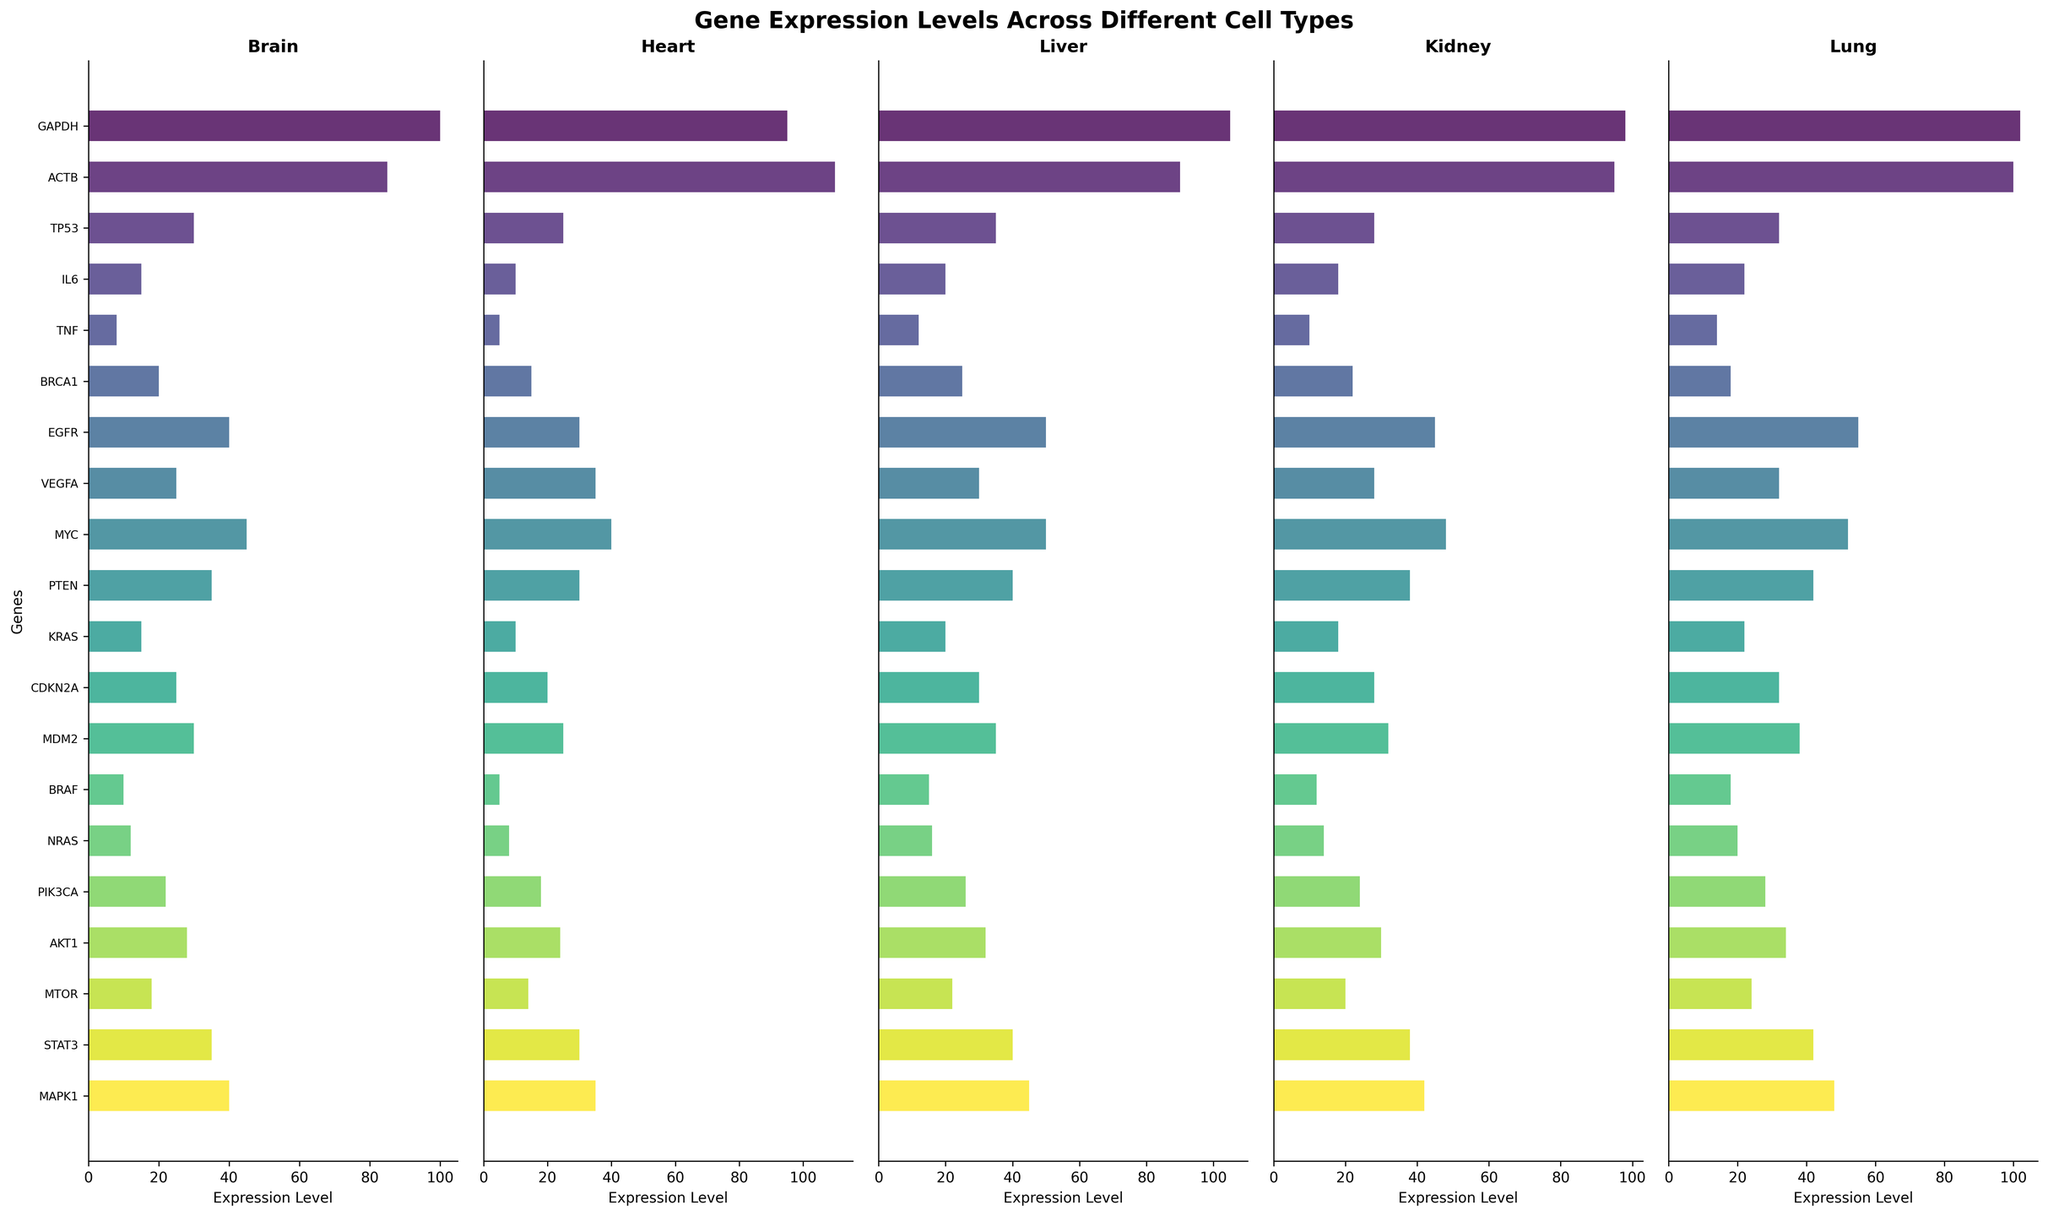What's the highest gene expression level in the Brain? To identify the highest gene expression level in the Brain, examine the heights of the bars in the Brain subplot. The tallest bar corresponds to GAPDH, which has an expression level of 100.
Answer: GAPDH with 100 Compare the expression levels of ACTB in the Liver and Kidney. Which cell type shows higher expression? Check the heights of the ACTB bars in the Liver and Kidney subplots. In the Liver, the expression level of ACTB is 90, while in the Kidney, it is 95. Hence, the Kidney has a higher expression level of ACTB than the Liver.
Answer: Kidney Which three genes have the lowest expression levels in the Heart? To find the three genes with the lowest expression levels in the Heart, look at the three shortest bars in the Heart subplot. These are TNF (5), NRAS (8) and IL6 (10).
Answer: TNF, NRAS, IL6 What's the average expression level of the gene VEGFA across all cell types? Sum the expression levels of VEGFA across all cell types: Brain (25) + Heart (35) + Liver (30) + Kidney (28) + Lung (32) = 150. Then divide by the number of cell types: 150 / 5 = 30.
Answer: 30 Is the expression level of TP53 in the Lung higher than in the Kidney? Compare the heights of the TP53 bars in the Lung and Kidney subplots. In the Lung, the TP53 expression level is 32, while in the Kidney it is 28. Therefore, the expression level in the Lung is higher.
Answer: Yes Which gene has the most consistent expression level across the different cell types? For each gene, check how similar the expression levels are across the five subplots. GAPDH shows minimal variation: Brain (100), Heart (95), Liver (105), Kidney (98), Lung (102), indicating it has the most consistent expression.
Answer: GAPDH Calculate the total expression level of MAPK1 across all cell types and determine its rank compared to other genes. Sum the expression levels of MAPK1 across all cell types: Brain (40) + Heart (35) + Liver (45) + Kidney (42) + Lung (48) = 210. Now sum the total values for all genes. MAPK1's total (210) ranks as one of the highest compared to other genes, ranking it highly.
Answer: High-ranking, total 210 Compare the expression levels of EGFR and MYC in the Brain. Which one has a higher expression level and by how much? In the Brain subplot, compare the heights of the EGFR and MYC bars. EGFR has an expression level of 40, and MYC has an expression level of 45. Thus, MYC is higher by 45 - 40 = 5.
Answer: MYC by 5 